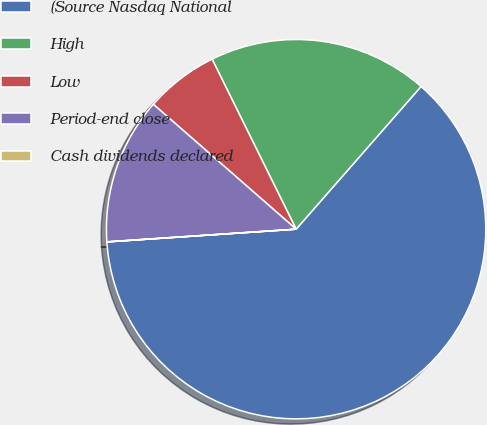Convert chart to OTSL. <chart><loc_0><loc_0><loc_500><loc_500><pie_chart><fcel>(Source Nasdaq National<fcel>High<fcel>Low<fcel>Period-end close<fcel>Cash dividends declared<nl><fcel>62.48%<fcel>18.75%<fcel>6.26%<fcel>12.5%<fcel>0.01%<nl></chart> 